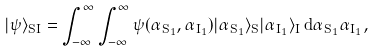<formula> <loc_0><loc_0><loc_500><loc_500>| \psi \rangle _ { S I } = \int _ { - \infty } ^ { \infty } \int _ { - \infty } ^ { \infty } \psi ( \alpha _ { S _ { 1 } } , \alpha _ { I _ { 1 } } ) | \alpha _ { S _ { 1 } } \rangle _ { S } | \alpha _ { I _ { 1 } } \rangle _ { I } \, d \alpha _ { S _ { 1 } } \alpha _ { I _ { 1 } } ,</formula> 